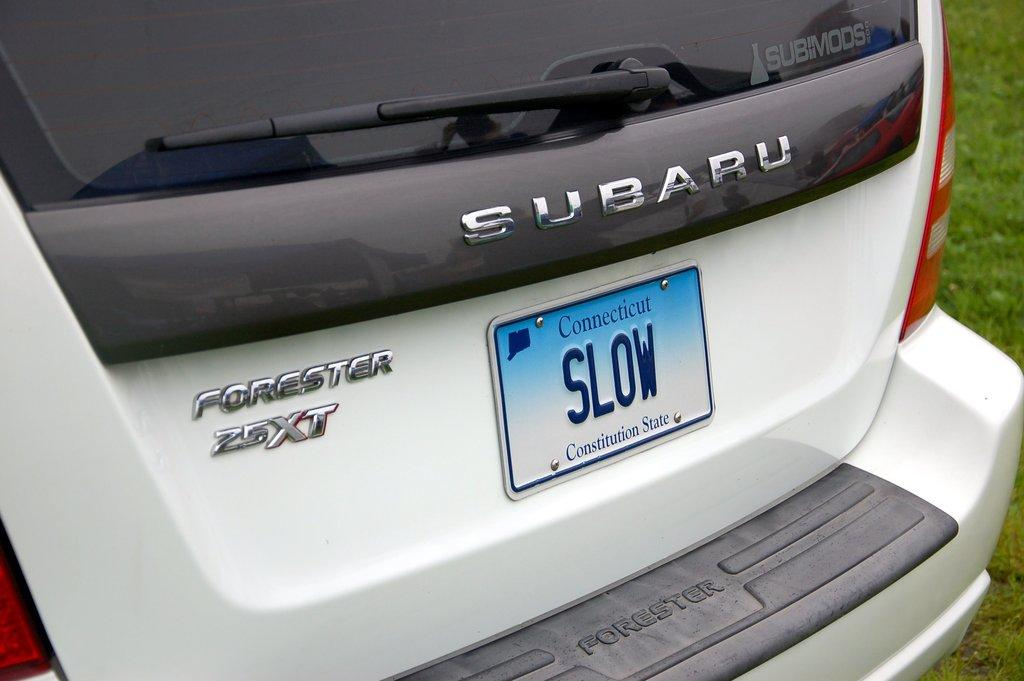Provide a one-sentence caption for the provided image. White Subaru van with a license plate that says "SLOW". 